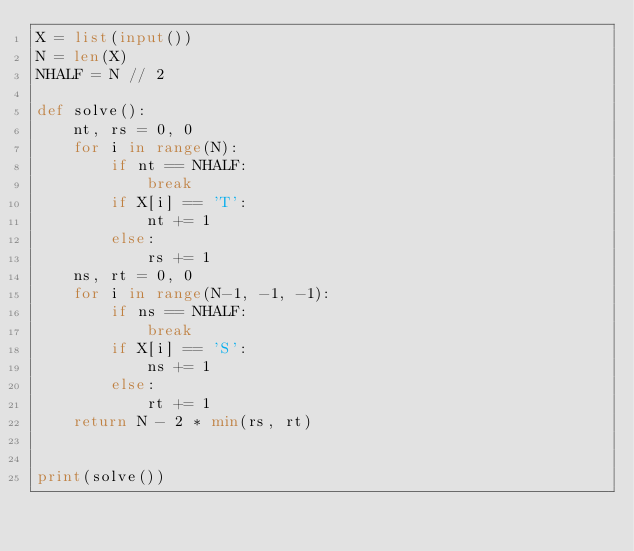<code> <loc_0><loc_0><loc_500><loc_500><_Python_>X = list(input())
N = len(X)
NHALF = N // 2

def solve():
    nt, rs = 0, 0
    for i in range(N):
        if nt == NHALF:
            break
        if X[i] == 'T':
            nt += 1
        else:
            rs += 1
    ns, rt = 0, 0
    for i in range(N-1, -1, -1):
        if ns == NHALF:
            break
        if X[i] == 'S':
            ns += 1
        else:
            rt += 1
    return N - 2 * min(rs, rt)


print(solve())</code> 